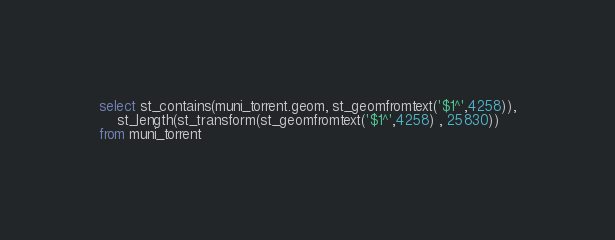<code> <loc_0><loc_0><loc_500><loc_500><_SQL_>select st_contains(muni_torrent.geom, st_geomfromtext('$1^',4258)),
	st_length(st_transform(st_geomfromtext('$1^',4258) , 25830)) 
from muni_torrent</code> 